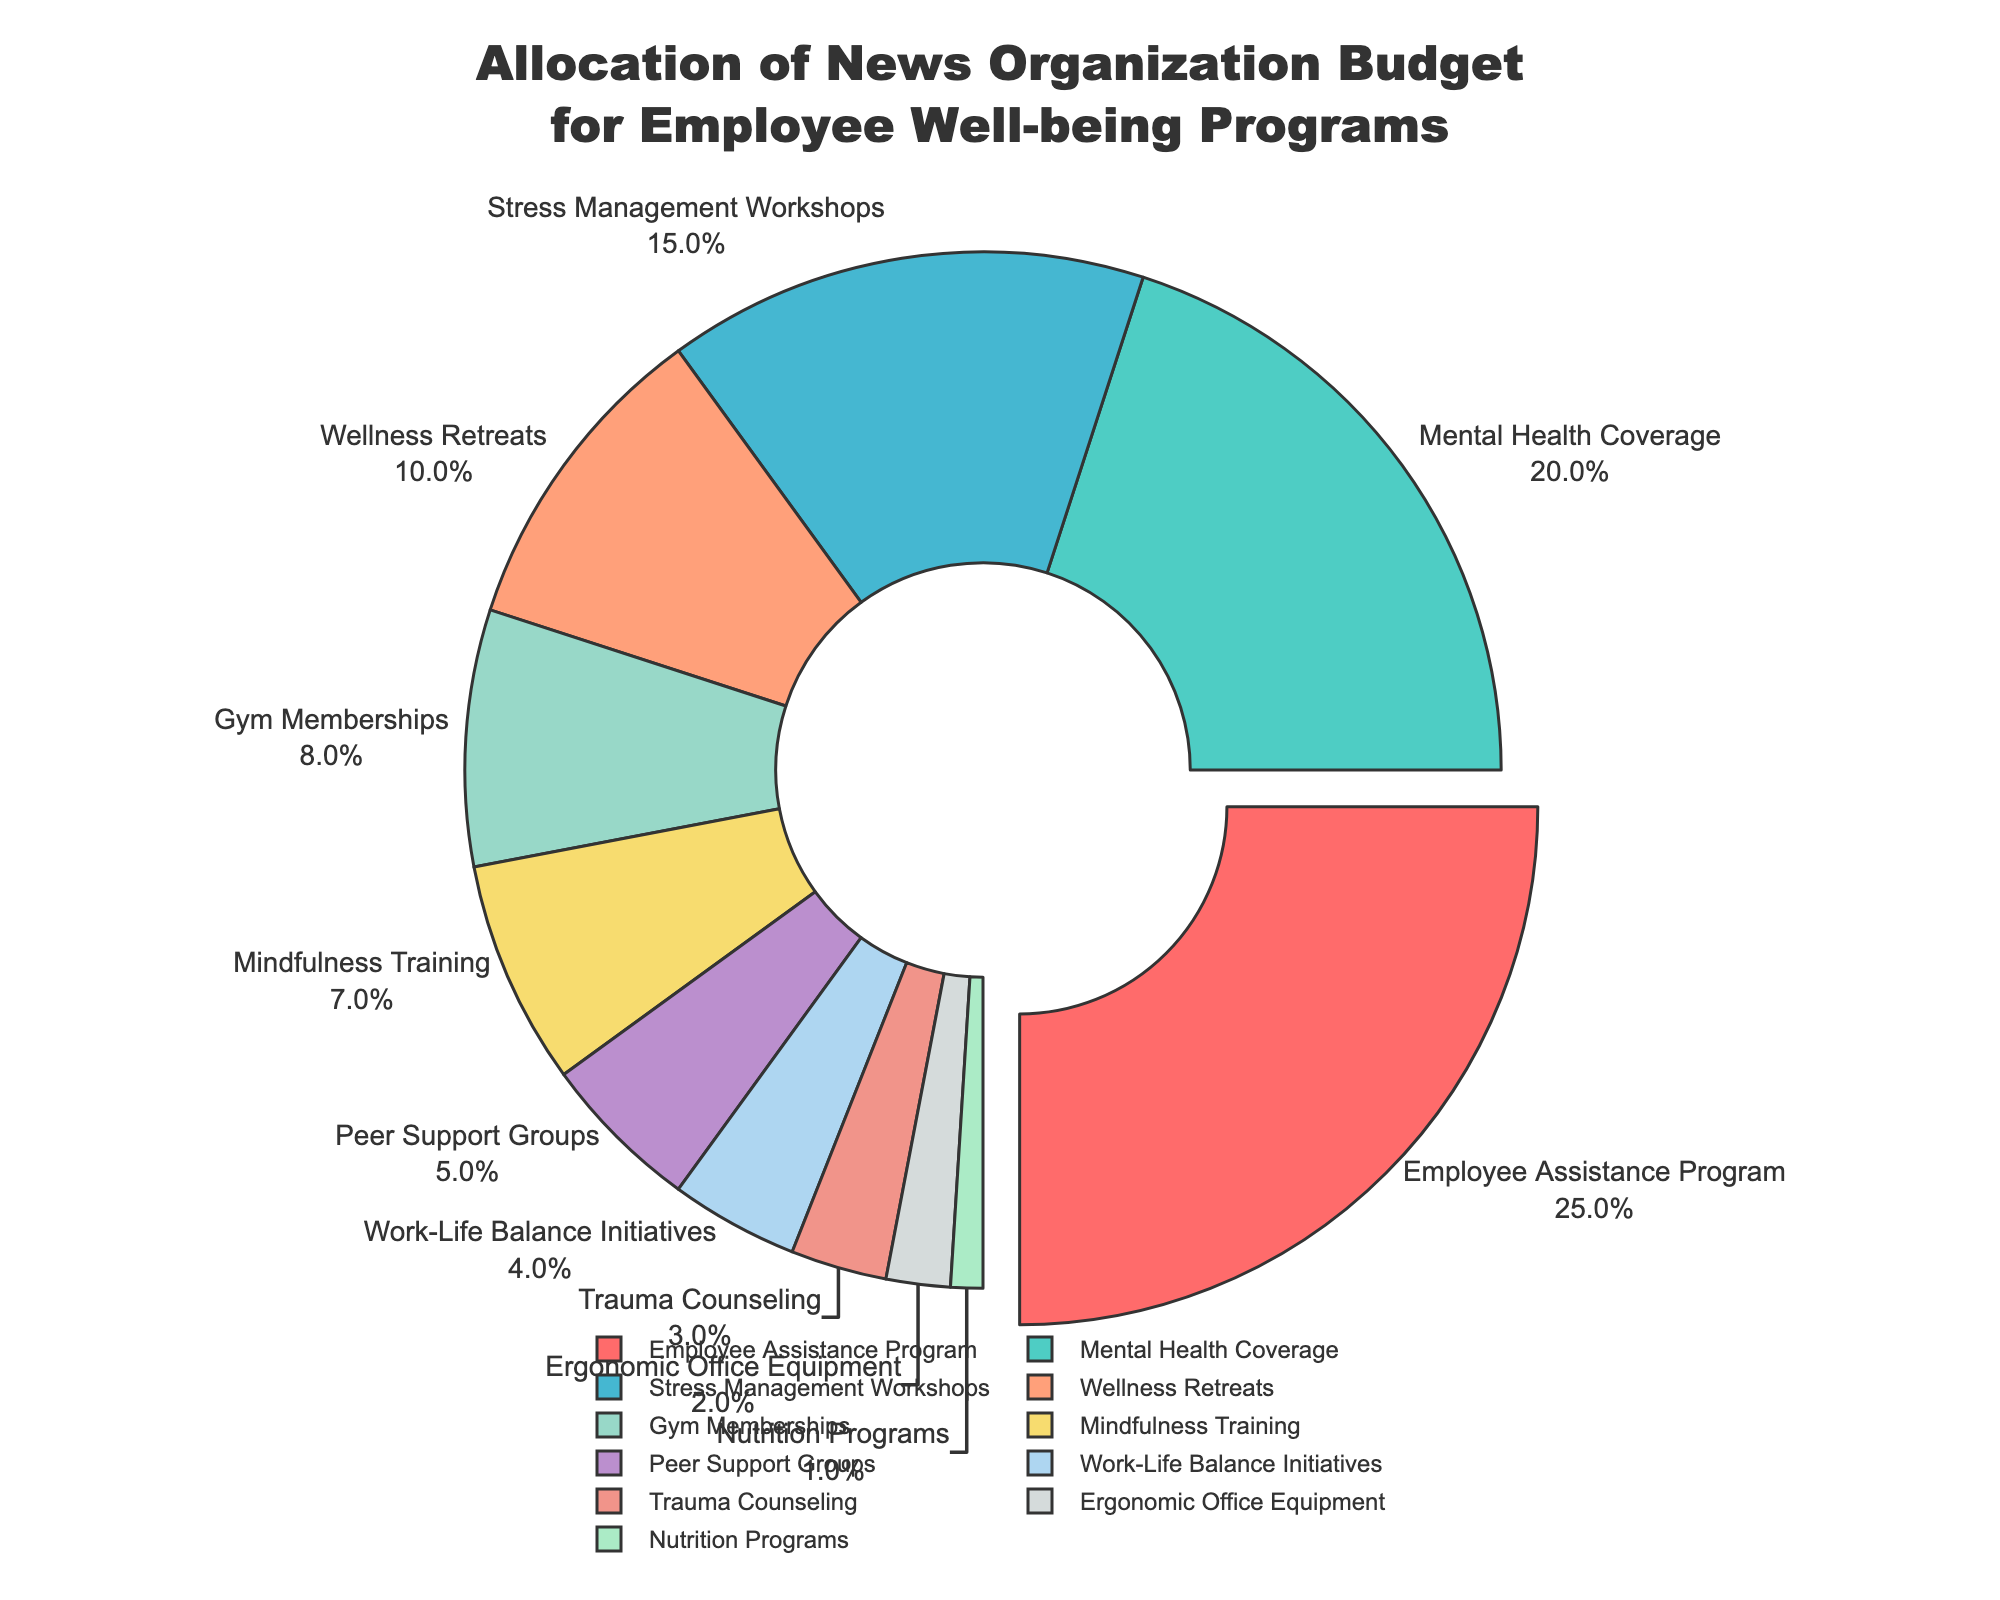What percentage of the budget is allocated to both Employee Assistance Program and Mental Health Coverage combined? To determine the combined percentage, add the percentages for Employee Assistance Program (25%) and Mental Health Coverage (20%). 25 + 20 = 45.
Answer: 45% Which category has the smallest allocation in the budget? To find the smallest allocation, look for the category with the smallest percentage. The Nutrition Programs category has 1%.
Answer: Nutrition Programs Which has more allocation, Gym Memberships or Stress Management Workshops? Compare the percentages for Gym Memberships (8%) and Stress Management Workshops (15%). 15 is greater than 8.
Answer: Stress Management Workshops By how much does the budget for Peer Support Groups exceed that for Trauma Counseling? Subtract the percentage for Trauma Counseling (3%) from Peer Support Groups (5%). 5 - 3 = 2.
Answer: 2% What is the approximate percentage of the budget allocated to Wellness Retreats represented visually? To answer this, identify the proportion labeled Wellness Retreats on the pie chart, which is 10%.
Answer: 10% Is the budget share for Mindfulness Training greater than or less than 10%? Compare the given percentage of Mindfulness Training (7%) to 10%. 7 is less than 10.
Answer: Less than 10% If the Employee Assistance Program allocation increases by 5%, what would its new allocation percentage be? Add 5% to the current Employee Assistance Program allocation (25%). 25 + 5 = 30.
Answer: 30% How much more is allocated to Ergonomic Office Equipment compared to Nutrition Programs? Subtract the percentage for Nutrition Programs (1%) from Ergonomic Office Equipment (2%). 2 - 1 = 1.
Answer: 1% What percentage of the budget is allocated to categories that have less than 10% each? Identify the categories with less than 10%: Gym Memberships (8%), Mindfulness Training (7%), Peer Support Groups (5%), Work-Life Balance Initiatives (4%), Trauma Counseling (3%), Ergonomic Office Equipment (2%), and Nutrition Programs (1%). Add these percentages: 8 + 7 + 5 + 4 + 3 + 2 + 1 = 30.
Answer: 30% How does the budget for Mental Health Coverage compare to the combined allocation for Nutrition Programs, Ergonomic Office Equipment, and Trauma Counseling? First, add the percentages for Nutrition Programs (1%), Ergonomic Office Equipment (2%), and Trauma Counseling (3%). 1 + 2 + 3 = 6. Then compare this sum to the Mental Health Coverage percentage (20%). 20 is greater than 6.
Answer: Greater 